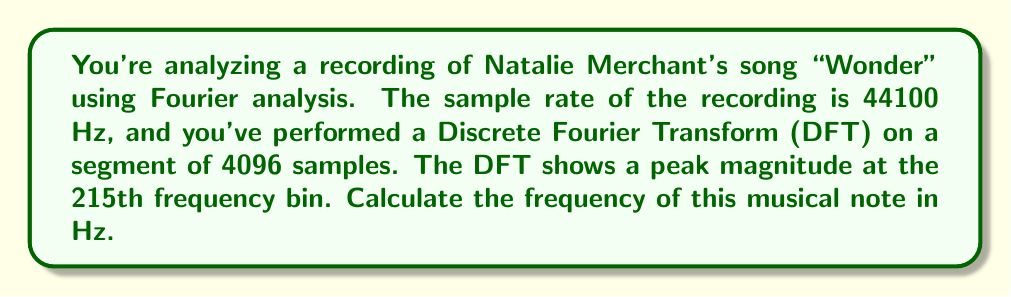What is the answer to this math problem? To solve this problem, we'll use the relationship between the DFT bin number, sample rate, and number of samples. The formula for calculating the frequency corresponding to a given DFT bin is:

$$ f = \frac{k \cdot f_s}{N} $$

Where:
$f$ is the frequency in Hz
$k$ is the bin number
$f_s$ is the sample rate
$N$ is the number of samples

Given:
$k = 215$ (215th frequency bin)
$f_s = 44100$ Hz (sample rate)
$N = 4096$ (number of samples)

Let's substitute these values into the formula:

$$ f = \frac{215 \cdot 44100}{4096} $$

Now, let's calculate:

$$ f = \frac{9481500}{4096} $$

$$ f \approx 2314.8193359375 $$

Rounding to two decimal places for practical purposes in music analysis:

$$ f \approx 2314.82 \text{ Hz} $$

This frequency corresponds to a musical note slightly above C#7 in the standard tuning system (C#7 is approximately 2217.46 Hz).
Answer: $2314.82 \text{ Hz}$ 